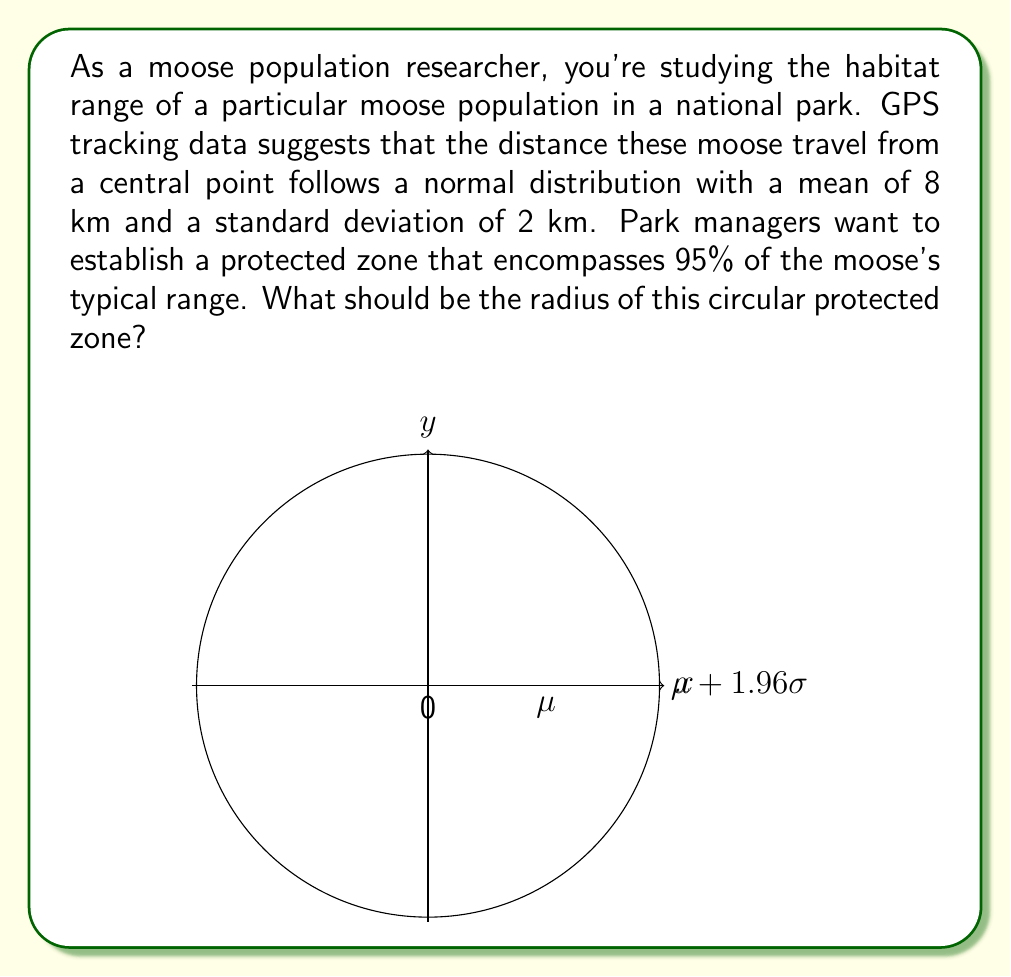Can you solve this math problem? To solve this problem, we'll use properties of the normal distribution:

1) We need to find the distance from the mean that encompasses 95% of the data. In a normal distribution, this corresponds to approximately 1.96 standard deviations from the mean (for a two-tailed 95% confidence interval).

2) The formula for this distance is:
   $$\text{Radius} = \mu + z \cdot \sigma$$
   where $\mu$ is the mean, $\sigma$ is the standard deviation, and $z$ is the z-score (1.96 for 95% confidence).

3) Given:
   $\mu = 8$ km
   $\sigma = 2$ km
   $z = 1.96$ (for 95% confidence)

4) Plugging these values into our formula:
   $$\text{Radius} = 8 + 1.96 \cdot 2$$

5) Calculating:
   $$\text{Radius} = 8 + 3.92 = 11.92$$

Therefore, the radius of the protected zone should be approximately 11.92 km to encompass 95% of the moose's typical range.
Answer: 11.92 km 